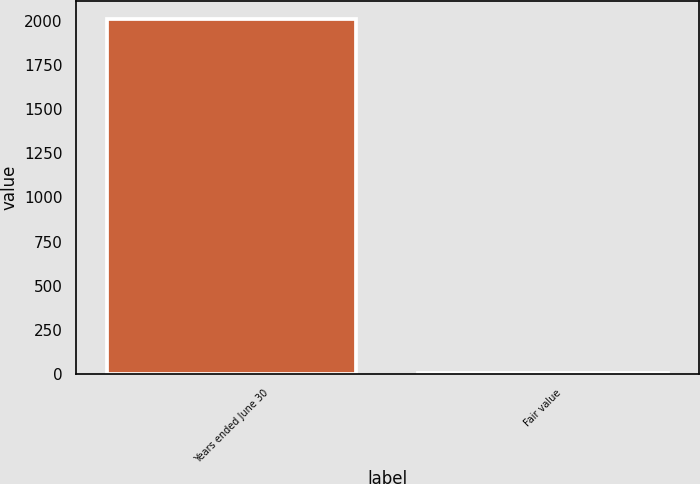<chart> <loc_0><loc_0><loc_500><loc_500><bar_chart><fcel>Years ended June 30<fcel>Fair value<nl><fcel>2009<fcel>7.54<nl></chart> 